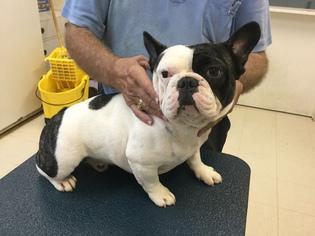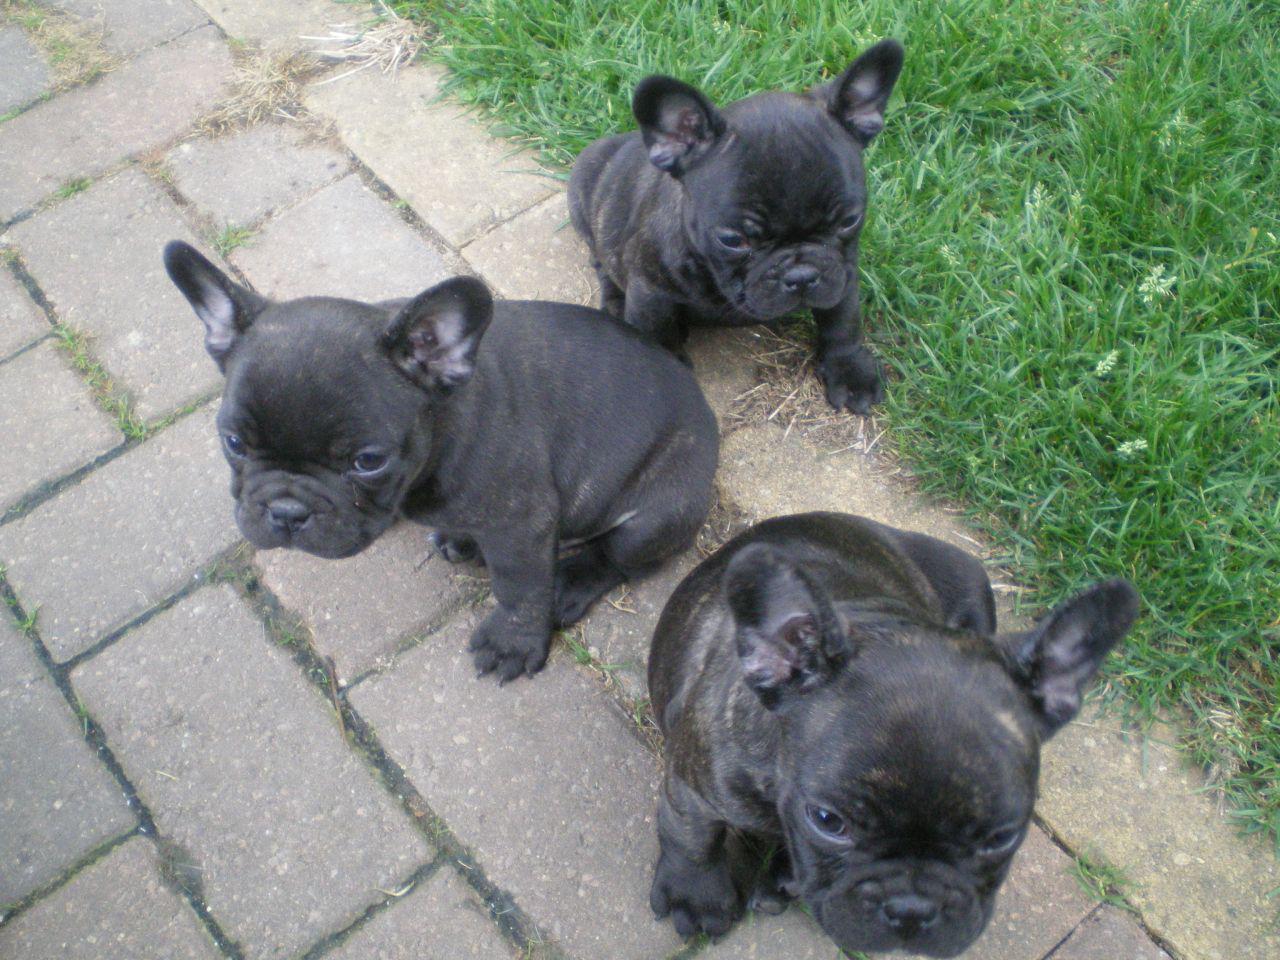The first image is the image on the left, the second image is the image on the right. Given the left and right images, does the statement "There are seven dogs." hold true? Answer yes or no. No. The first image is the image on the left, the second image is the image on the right. Considering the images on both sides, is "there are three french bulldogs, the dog in the middle has a white chest" valid? Answer yes or no. No. 